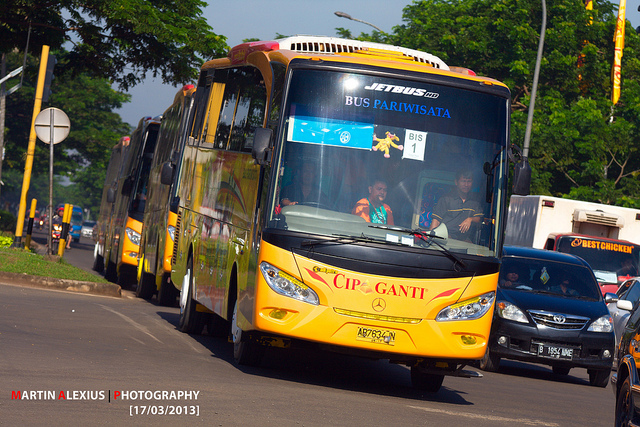Can you describe the main features of this image for me? The image shows a vibrant, yellow tourist bus prominently positioned in the foreground. The bus, labeled 'CIP GANTI,' features six windshield wipers across its large front window, designed for optimal visibility in various weather conditions. Visible towards the bottom-right and bottom-center are two license plates. The interior of the bus reveals three ventilation systems located at different points. Interestingly, two steering wheels can be observed, indicating perhaps the main driver's position and another for auxiliary use. The bus is part of a convoy as other similar buses are visible in the background. The setting appears to be a street lined with greenery and other vehicles. 